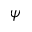Convert formula to latex. <formula><loc_0><loc_0><loc_500><loc_500>\psi</formula> 